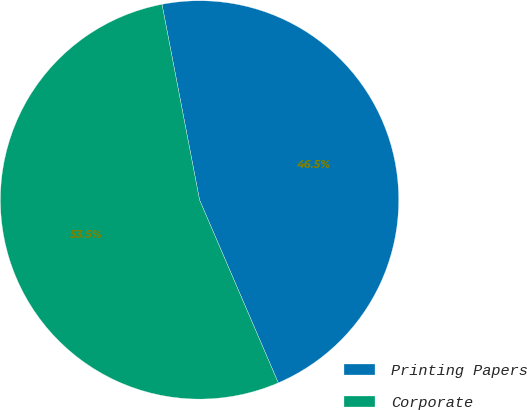Convert chart. <chart><loc_0><loc_0><loc_500><loc_500><pie_chart><fcel>Printing Papers<fcel>Corporate<nl><fcel>46.55%<fcel>53.45%<nl></chart> 